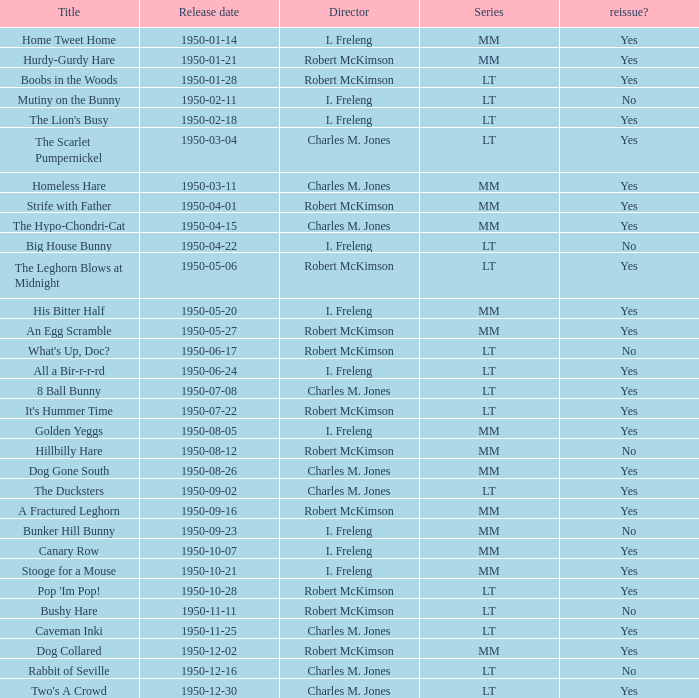Who directed Bunker Hill Bunny? I. Freleng. 